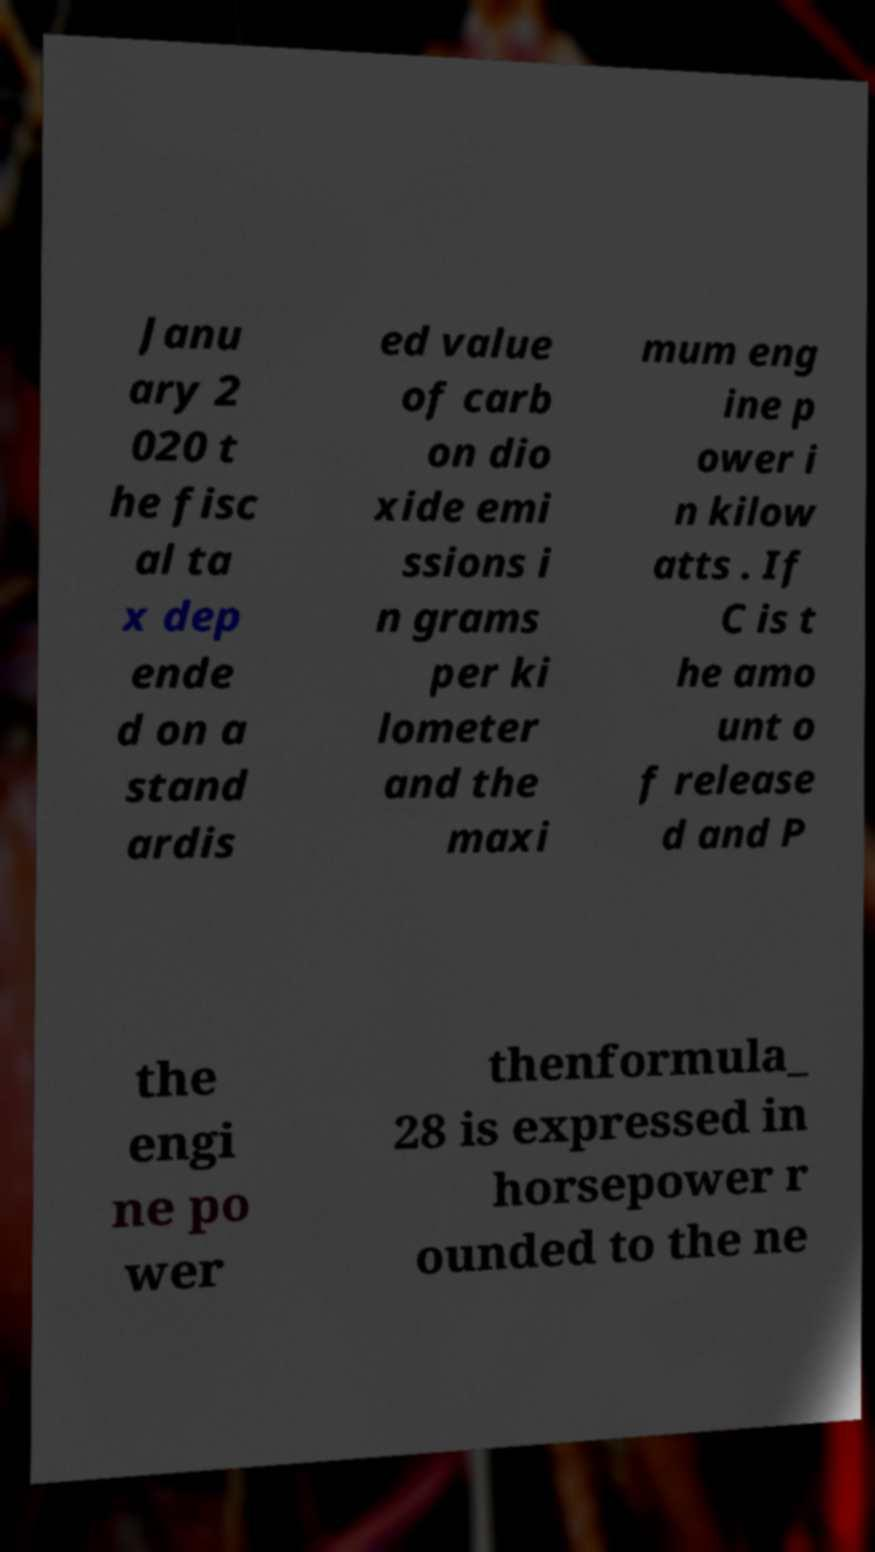Can you read and provide the text displayed in the image?This photo seems to have some interesting text. Can you extract and type it out for me? Janu ary 2 020 t he fisc al ta x dep ende d on a stand ardis ed value of carb on dio xide emi ssions i n grams per ki lometer and the maxi mum eng ine p ower i n kilow atts . If C is t he amo unt o f release d and P the engi ne po wer thenformula_ 28 is expressed in horsepower r ounded to the ne 